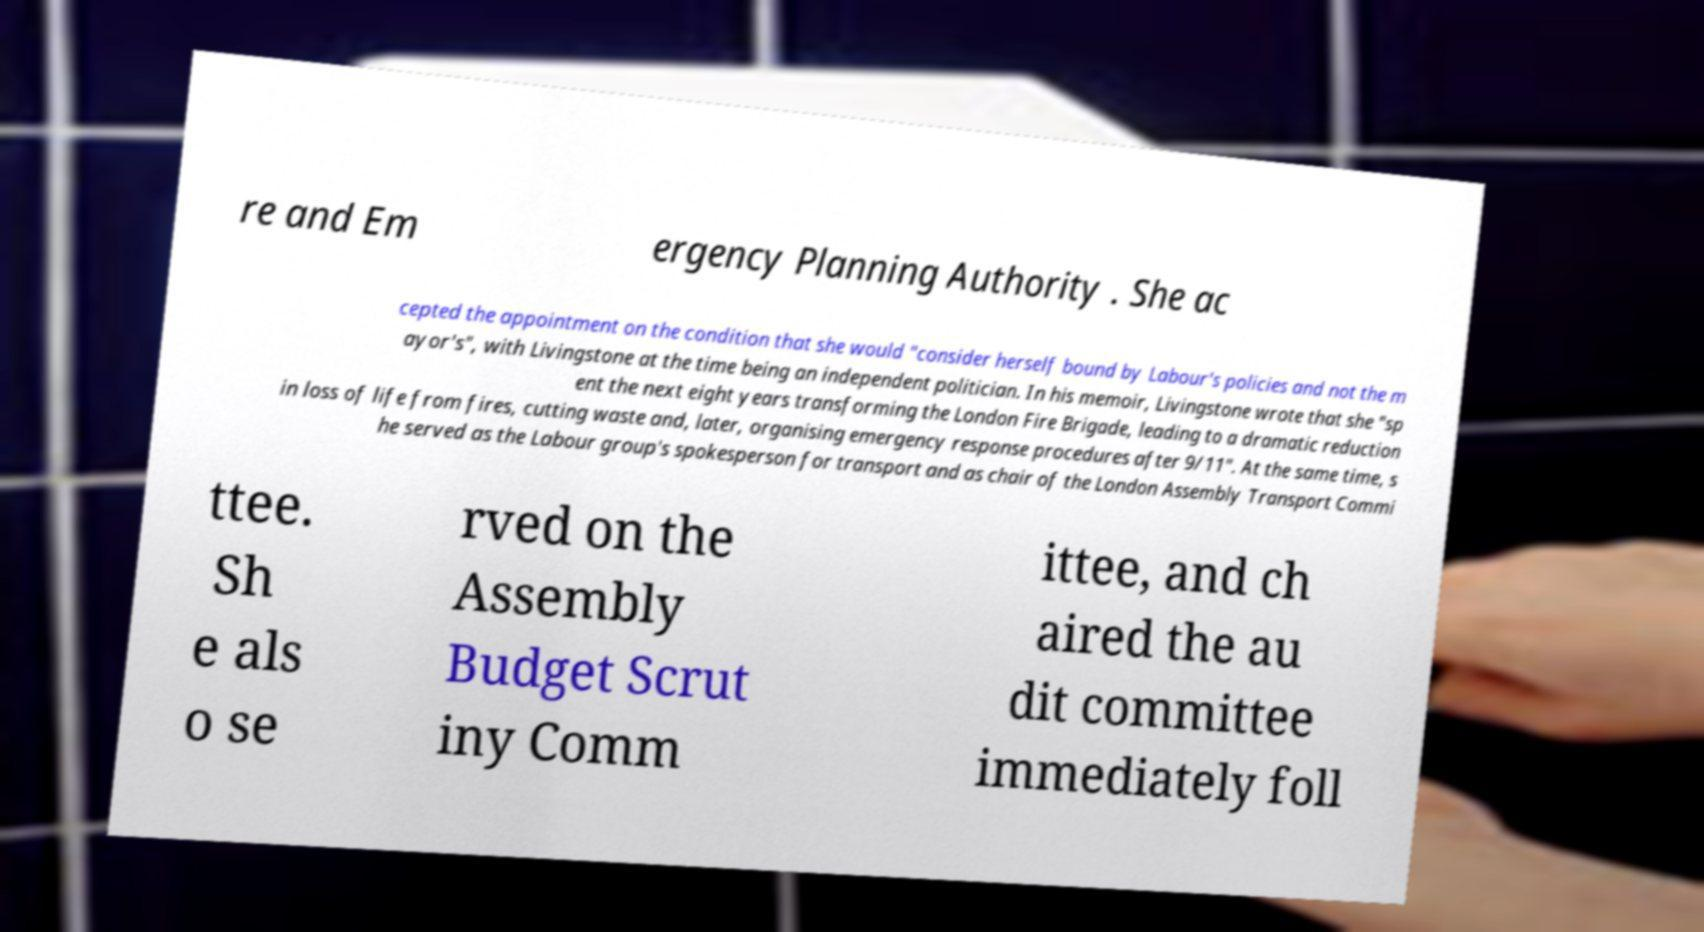What messages or text are displayed in this image? I need them in a readable, typed format. re and Em ergency Planning Authority . She ac cepted the appointment on the condition that she would "consider herself bound by Labour's policies and not the m ayor's", with Livingstone at the time being an independent politician. In his memoir, Livingstone wrote that she "sp ent the next eight years transforming the London Fire Brigade, leading to a dramatic reduction in loss of life from fires, cutting waste and, later, organising emergency response procedures after 9/11". At the same time, s he served as the Labour group's spokesperson for transport and as chair of the London Assembly Transport Commi ttee. Sh e als o se rved on the Assembly Budget Scrut iny Comm ittee, and ch aired the au dit committee immediately foll 